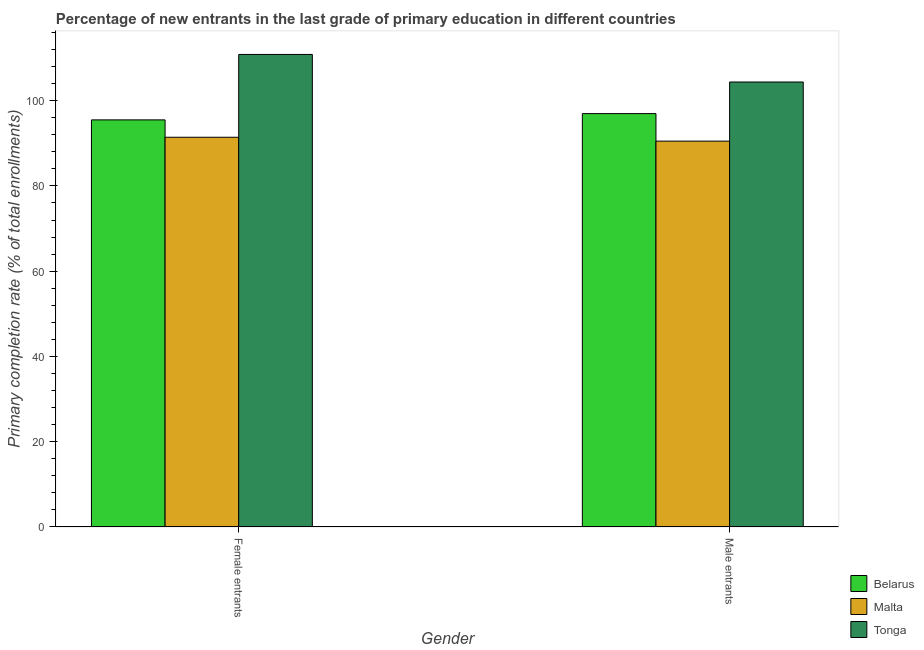Are the number of bars on each tick of the X-axis equal?
Your answer should be compact. Yes. What is the label of the 1st group of bars from the left?
Your response must be concise. Female entrants. What is the primary completion rate of male entrants in Malta?
Provide a short and direct response. 90.5. Across all countries, what is the maximum primary completion rate of female entrants?
Keep it short and to the point. 110.83. Across all countries, what is the minimum primary completion rate of male entrants?
Your answer should be compact. 90.5. In which country was the primary completion rate of male entrants maximum?
Provide a short and direct response. Tonga. In which country was the primary completion rate of male entrants minimum?
Offer a terse response. Malta. What is the total primary completion rate of male entrants in the graph?
Make the answer very short. 291.83. What is the difference between the primary completion rate of female entrants in Malta and that in Tonga?
Your response must be concise. -19.42. What is the difference between the primary completion rate of female entrants in Tonga and the primary completion rate of male entrants in Belarus?
Your response must be concise. 13.87. What is the average primary completion rate of female entrants per country?
Provide a succinct answer. 99.24. What is the difference between the primary completion rate of male entrants and primary completion rate of female entrants in Belarus?
Provide a short and direct response. 1.47. What is the ratio of the primary completion rate of female entrants in Malta to that in Tonga?
Ensure brevity in your answer.  0.82. In how many countries, is the primary completion rate of female entrants greater than the average primary completion rate of female entrants taken over all countries?
Ensure brevity in your answer.  1. What does the 2nd bar from the left in Female entrants represents?
Provide a short and direct response. Malta. What does the 2nd bar from the right in Female entrants represents?
Provide a succinct answer. Malta. How many bars are there?
Ensure brevity in your answer.  6. How many countries are there in the graph?
Your answer should be very brief. 3. What is the difference between two consecutive major ticks on the Y-axis?
Keep it short and to the point. 20. Are the values on the major ticks of Y-axis written in scientific E-notation?
Your response must be concise. No. Does the graph contain grids?
Your response must be concise. No. How many legend labels are there?
Provide a short and direct response. 3. How are the legend labels stacked?
Offer a very short reply. Vertical. What is the title of the graph?
Offer a very short reply. Percentage of new entrants in the last grade of primary education in different countries. Does "Senegal" appear as one of the legend labels in the graph?
Offer a very short reply. No. What is the label or title of the Y-axis?
Keep it short and to the point. Primary completion rate (% of total enrollments). What is the Primary completion rate (% of total enrollments) in Belarus in Female entrants?
Offer a very short reply. 95.49. What is the Primary completion rate (% of total enrollments) of Malta in Female entrants?
Ensure brevity in your answer.  91.41. What is the Primary completion rate (% of total enrollments) of Tonga in Female entrants?
Your response must be concise. 110.83. What is the Primary completion rate (% of total enrollments) in Belarus in Male entrants?
Your answer should be very brief. 96.96. What is the Primary completion rate (% of total enrollments) of Malta in Male entrants?
Your answer should be compact. 90.5. What is the Primary completion rate (% of total enrollments) of Tonga in Male entrants?
Give a very brief answer. 104.37. Across all Gender, what is the maximum Primary completion rate (% of total enrollments) in Belarus?
Provide a short and direct response. 96.96. Across all Gender, what is the maximum Primary completion rate (% of total enrollments) in Malta?
Your response must be concise. 91.41. Across all Gender, what is the maximum Primary completion rate (% of total enrollments) of Tonga?
Provide a short and direct response. 110.83. Across all Gender, what is the minimum Primary completion rate (% of total enrollments) in Belarus?
Make the answer very short. 95.49. Across all Gender, what is the minimum Primary completion rate (% of total enrollments) of Malta?
Your answer should be very brief. 90.5. Across all Gender, what is the minimum Primary completion rate (% of total enrollments) of Tonga?
Your response must be concise. 104.37. What is the total Primary completion rate (% of total enrollments) of Belarus in the graph?
Your answer should be compact. 192.44. What is the total Primary completion rate (% of total enrollments) of Malta in the graph?
Ensure brevity in your answer.  181.91. What is the total Primary completion rate (% of total enrollments) of Tonga in the graph?
Make the answer very short. 215.2. What is the difference between the Primary completion rate (% of total enrollments) of Belarus in Female entrants and that in Male entrants?
Your answer should be compact. -1.47. What is the difference between the Primary completion rate (% of total enrollments) of Malta in Female entrants and that in Male entrants?
Your answer should be compact. 0.91. What is the difference between the Primary completion rate (% of total enrollments) in Tonga in Female entrants and that in Male entrants?
Ensure brevity in your answer.  6.46. What is the difference between the Primary completion rate (% of total enrollments) in Belarus in Female entrants and the Primary completion rate (% of total enrollments) in Malta in Male entrants?
Offer a very short reply. 4.99. What is the difference between the Primary completion rate (% of total enrollments) of Belarus in Female entrants and the Primary completion rate (% of total enrollments) of Tonga in Male entrants?
Your answer should be compact. -8.88. What is the difference between the Primary completion rate (% of total enrollments) of Malta in Female entrants and the Primary completion rate (% of total enrollments) of Tonga in Male entrants?
Offer a terse response. -12.96. What is the average Primary completion rate (% of total enrollments) of Belarus per Gender?
Your answer should be very brief. 96.22. What is the average Primary completion rate (% of total enrollments) of Malta per Gender?
Your answer should be very brief. 90.95. What is the average Primary completion rate (% of total enrollments) in Tonga per Gender?
Provide a succinct answer. 107.6. What is the difference between the Primary completion rate (% of total enrollments) in Belarus and Primary completion rate (% of total enrollments) in Malta in Female entrants?
Make the answer very short. 4.08. What is the difference between the Primary completion rate (% of total enrollments) of Belarus and Primary completion rate (% of total enrollments) of Tonga in Female entrants?
Offer a terse response. -15.34. What is the difference between the Primary completion rate (% of total enrollments) in Malta and Primary completion rate (% of total enrollments) in Tonga in Female entrants?
Your answer should be compact. -19.42. What is the difference between the Primary completion rate (% of total enrollments) of Belarus and Primary completion rate (% of total enrollments) of Malta in Male entrants?
Provide a short and direct response. 6.46. What is the difference between the Primary completion rate (% of total enrollments) of Belarus and Primary completion rate (% of total enrollments) of Tonga in Male entrants?
Provide a succinct answer. -7.41. What is the difference between the Primary completion rate (% of total enrollments) of Malta and Primary completion rate (% of total enrollments) of Tonga in Male entrants?
Provide a short and direct response. -13.87. What is the ratio of the Primary completion rate (% of total enrollments) of Malta in Female entrants to that in Male entrants?
Your answer should be compact. 1.01. What is the ratio of the Primary completion rate (% of total enrollments) of Tonga in Female entrants to that in Male entrants?
Your response must be concise. 1.06. What is the difference between the highest and the second highest Primary completion rate (% of total enrollments) in Belarus?
Offer a terse response. 1.47. What is the difference between the highest and the second highest Primary completion rate (% of total enrollments) in Malta?
Offer a very short reply. 0.91. What is the difference between the highest and the second highest Primary completion rate (% of total enrollments) in Tonga?
Provide a succinct answer. 6.46. What is the difference between the highest and the lowest Primary completion rate (% of total enrollments) in Belarus?
Provide a short and direct response. 1.47. What is the difference between the highest and the lowest Primary completion rate (% of total enrollments) of Malta?
Your answer should be compact. 0.91. What is the difference between the highest and the lowest Primary completion rate (% of total enrollments) in Tonga?
Keep it short and to the point. 6.46. 